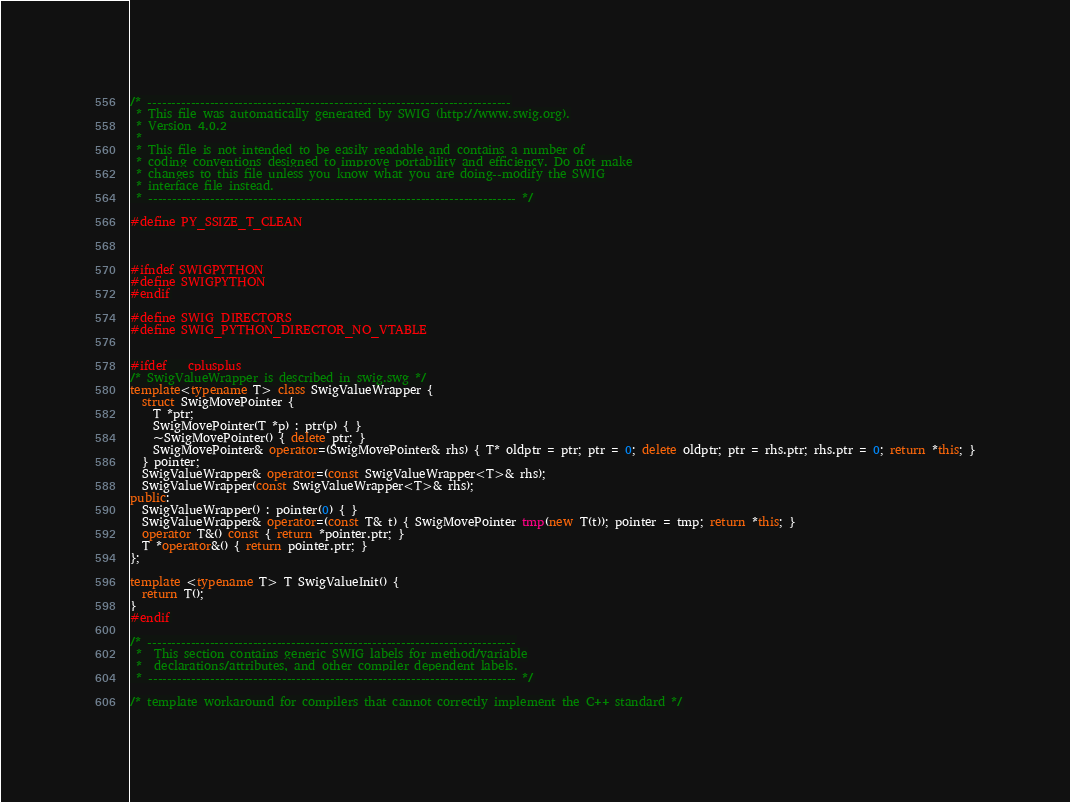<code> <loc_0><loc_0><loc_500><loc_500><_C++_>/* ----------------------------------------------------------------------------
 * This file was automatically generated by SWIG (http://www.swig.org).
 * Version 4.0.2
 *
 * This file is not intended to be easily readable and contains a number of
 * coding conventions designed to improve portability and efficiency. Do not make
 * changes to this file unless you know what you are doing--modify the SWIG
 * interface file instead.
 * ----------------------------------------------------------------------------- */

#define PY_SSIZE_T_CLEAN



#ifndef SWIGPYTHON
#define SWIGPYTHON
#endif

#define SWIG_DIRECTORS
#define SWIG_PYTHON_DIRECTOR_NO_VTABLE


#ifdef __cplusplus
/* SwigValueWrapper is described in swig.swg */
template<typename T> class SwigValueWrapper {
  struct SwigMovePointer {
    T *ptr;
    SwigMovePointer(T *p) : ptr(p) { }
    ~SwigMovePointer() { delete ptr; }
    SwigMovePointer& operator=(SwigMovePointer& rhs) { T* oldptr = ptr; ptr = 0; delete oldptr; ptr = rhs.ptr; rhs.ptr = 0; return *this; }
  } pointer;
  SwigValueWrapper& operator=(const SwigValueWrapper<T>& rhs);
  SwigValueWrapper(const SwigValueWrapper<T>& rhs);
public:
  SwigValueWrapper() : pointer(0) { }
  SwigValueWrapper& operator=(const T& t) { SwigMovePointer tmp(new T(t)); pointer = tmp; return *this; }
  operator T&() const { return *pointer.ptr; }
  T *operator&() { return pointer.ptr; }
};

template <typename T> T SwigValueInit() {
  return T();
}
#endif

/* -----------------------------------------------------------------------------
 *  This section contains generic SWIG labels for method/variable
 *  declarations/attributes, and other compiler dependent labels.
 * ----------------------------------------------------------------------------- */

/* template workaround for compilers that cannot correctly implement the C++ standard */</code> 